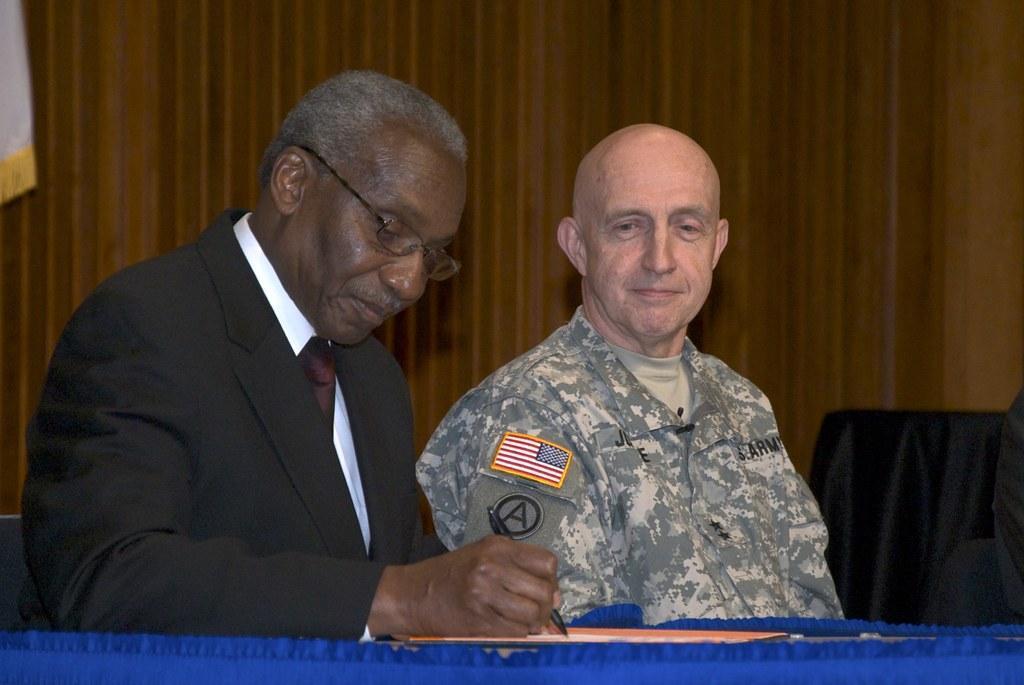In one or two sentences, can you explain what this image depicts? In this picture there is a man on the left side of the image, by placing his hands on the table, it seems to be there is a soldier beside him and there is a black color curtain in the background area of the image. 